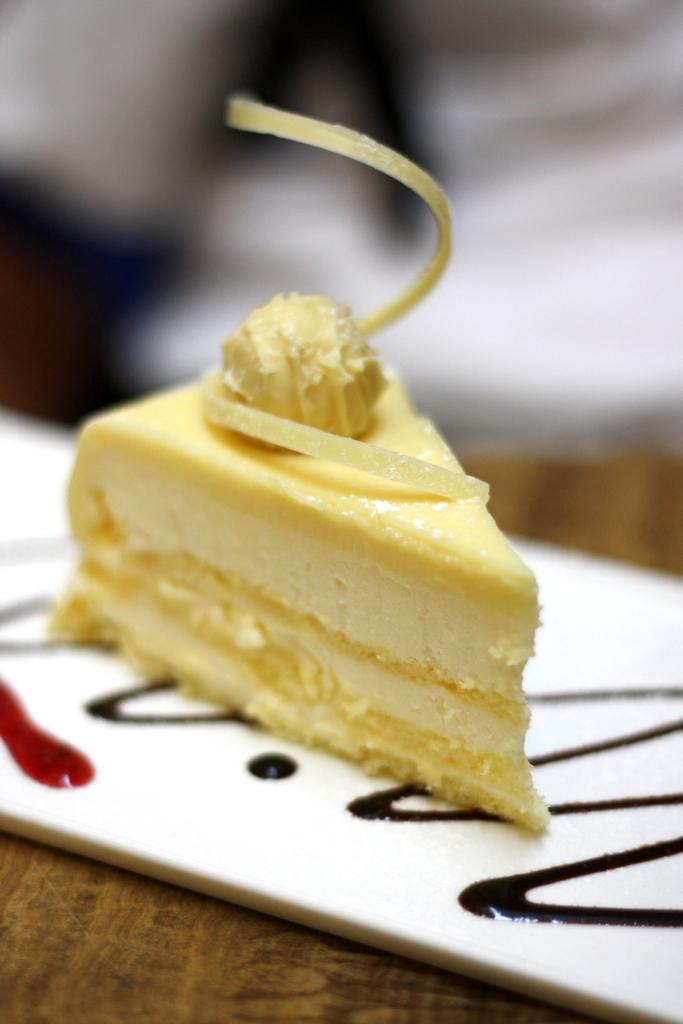What is the main subject of the image? There is a cake on a plate in the image. Where is the plate with the cake located? The plate is on a wooden surface. Can you describe the background of the image? The background of the image is blurred. How many bites have been taken out of the cake in the image? There is no indication of any bites taken out of the cake in the image. What type of mountain can be seen in the background of the image? There is no mountain present in the image; the background is blurred. 